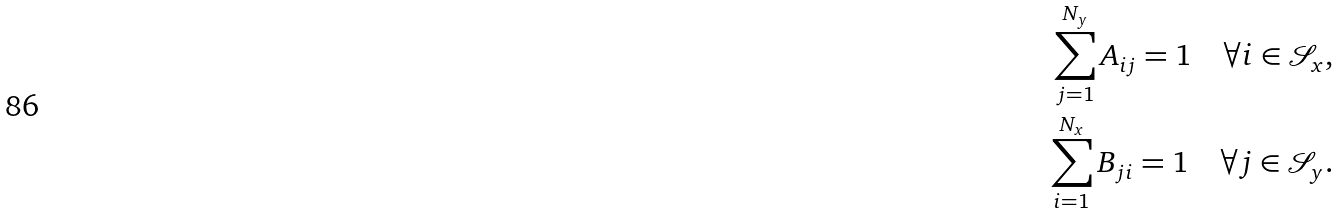<formula> <loc_0><loc_0><loc_500><loc_500>\sum _ { j = 1 } ^ { N _ { y } } A _ { i j } = 1 \quad \forall i \in \mathcal { S } _ { x } , \\ \sum _ { i = 1 } ^ { N _ { x } } B _ { j i } = 1 \quad \forall j \in \mathcal { S } _ { y } .</formula> 